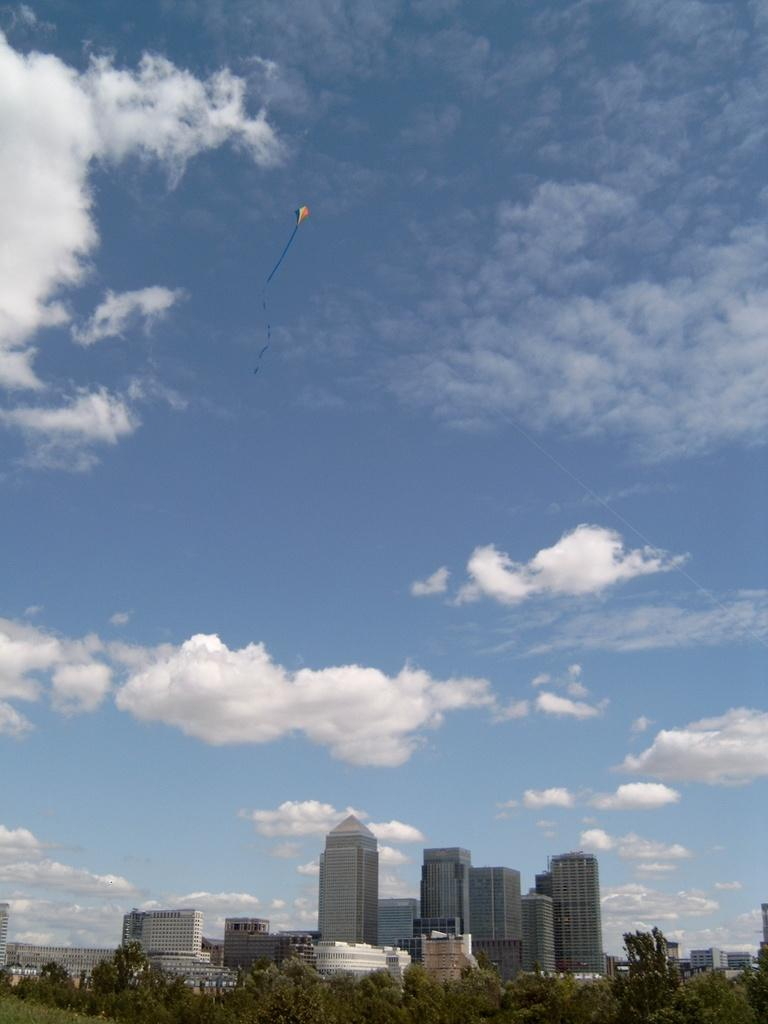What can be seen at the bottom of the image? There are trees and buildings at the bottom of the image. What is visible in the background of the image? Sky is visible in the background of the image. What can be observed in the sky? Clouds are present in the sky. What is flying in the air in the image? There is a kite flying in the air. How much tax is being paid for the kite in the image? There is no indication of tax being paid for the kite in the image, as it is a visual representation and not a real-life scenario. 